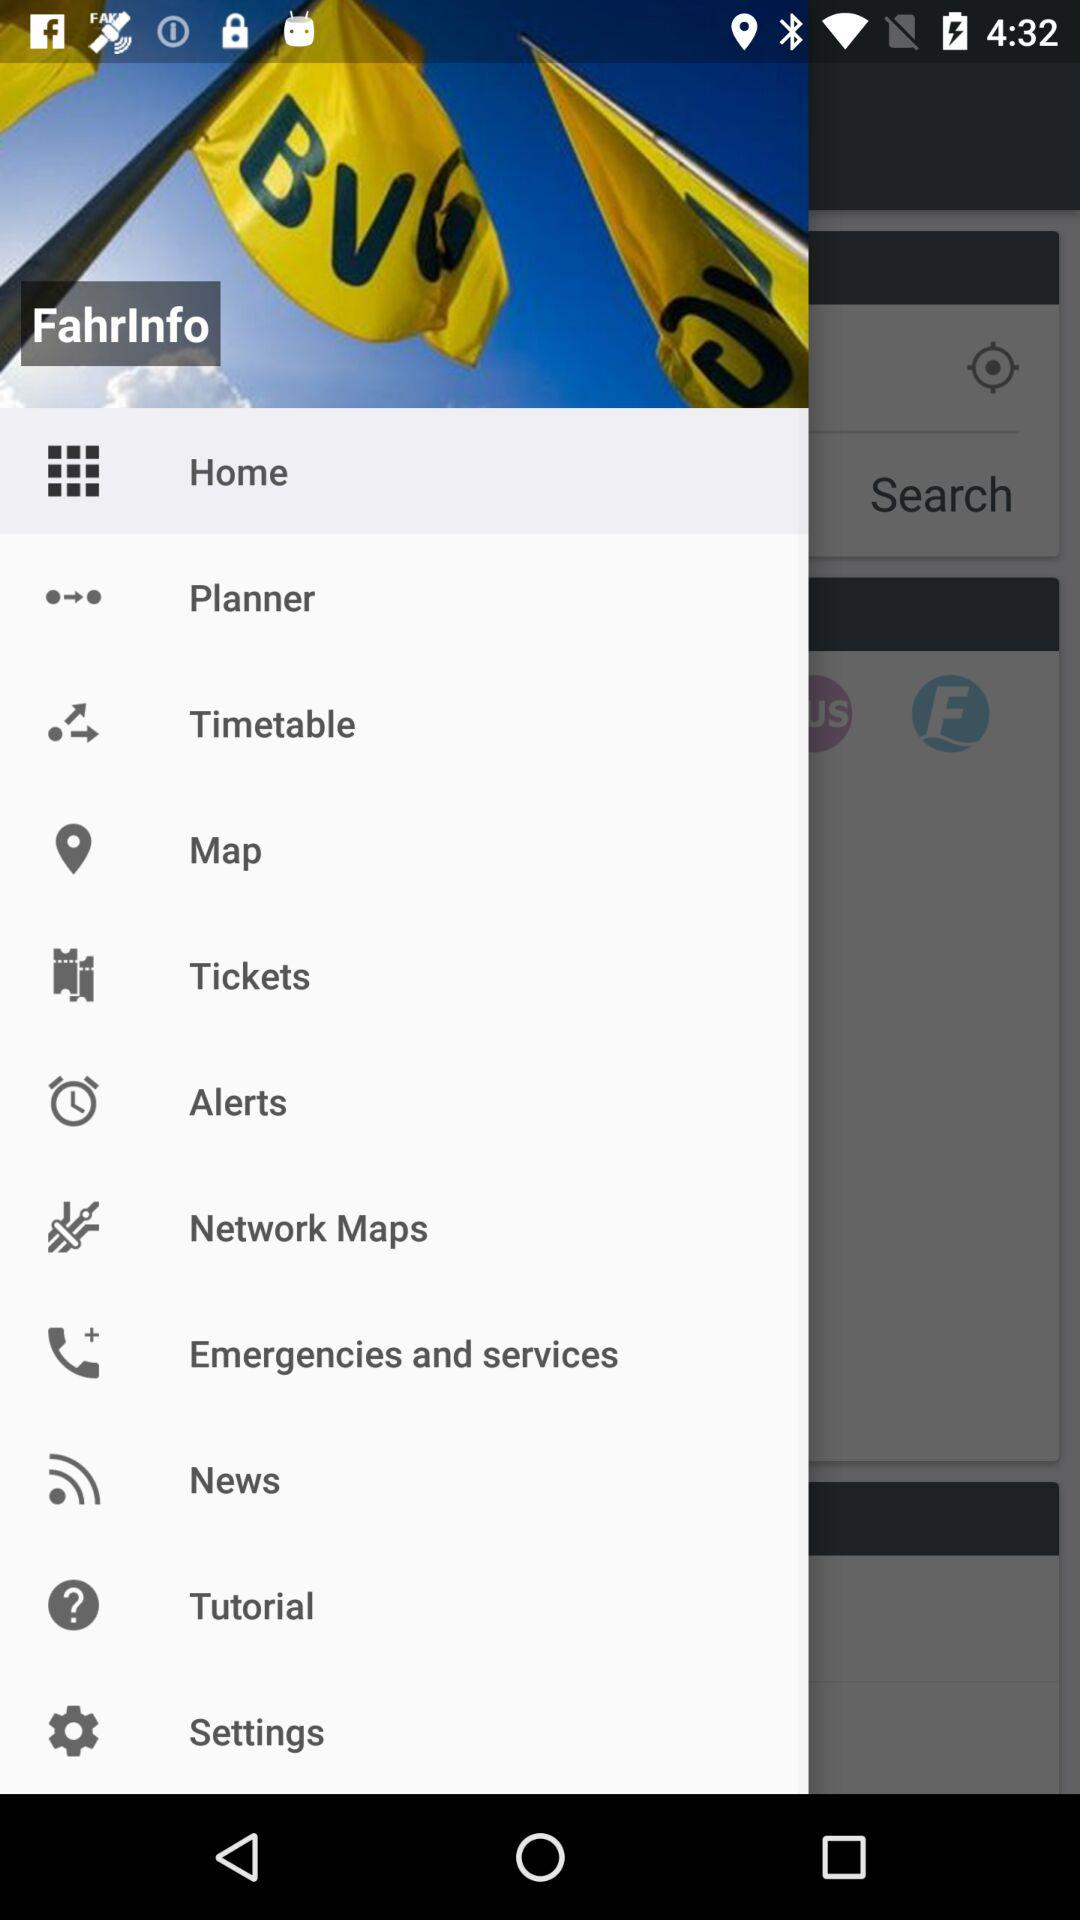What is the application name? The application name is "FahrInfo". 